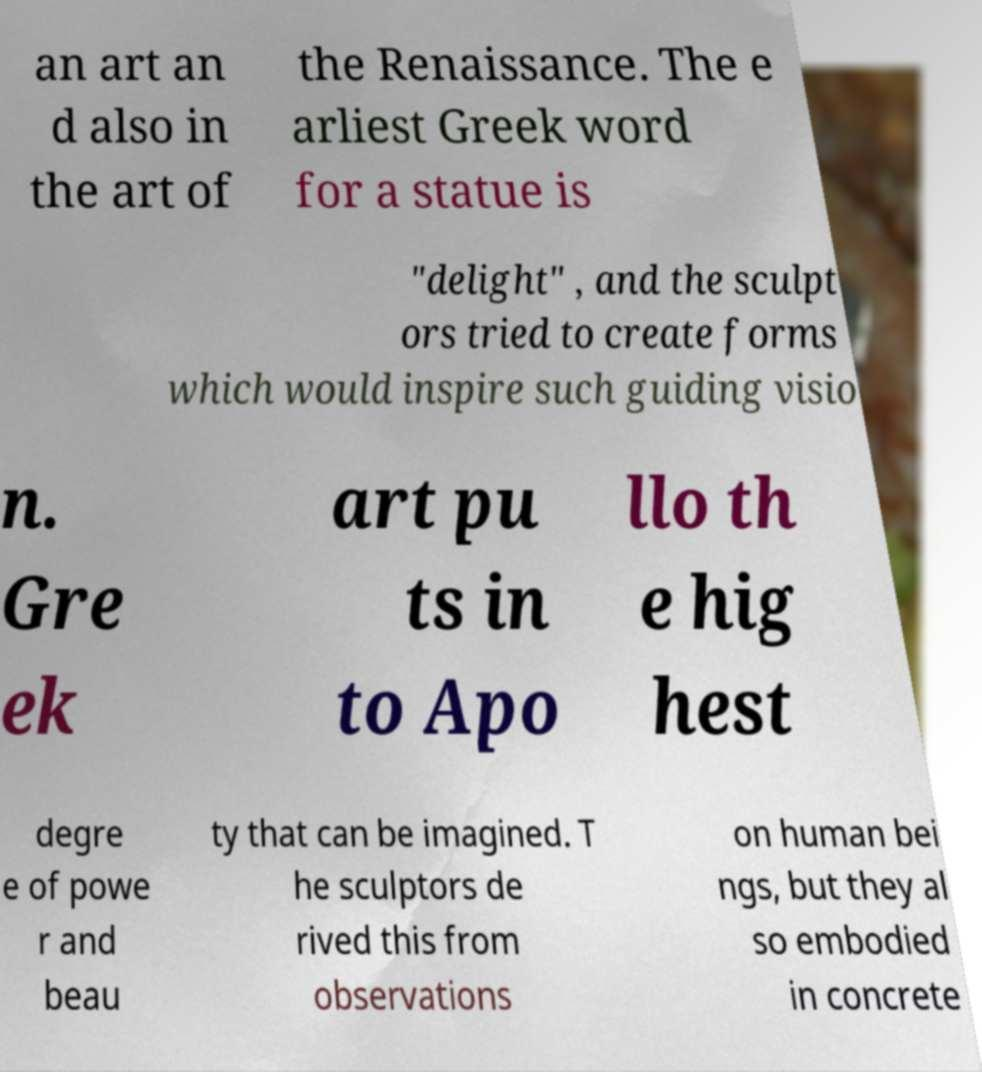Could you assist in decoding the text presented in this image and type it out clearly? an art an d also in the art of the Renaissance. The e arliest Greek word for a statue is "delight" , and the sculpt ors tried to create forms which would inspire such guiding visio n. Gre ek art pu ts in to Apo llo th e hig hest degre e of powe r and beau ty that can be imagined. T he sculptors de rived this from observations on human bei ngs, but they al so embodied in concrete 